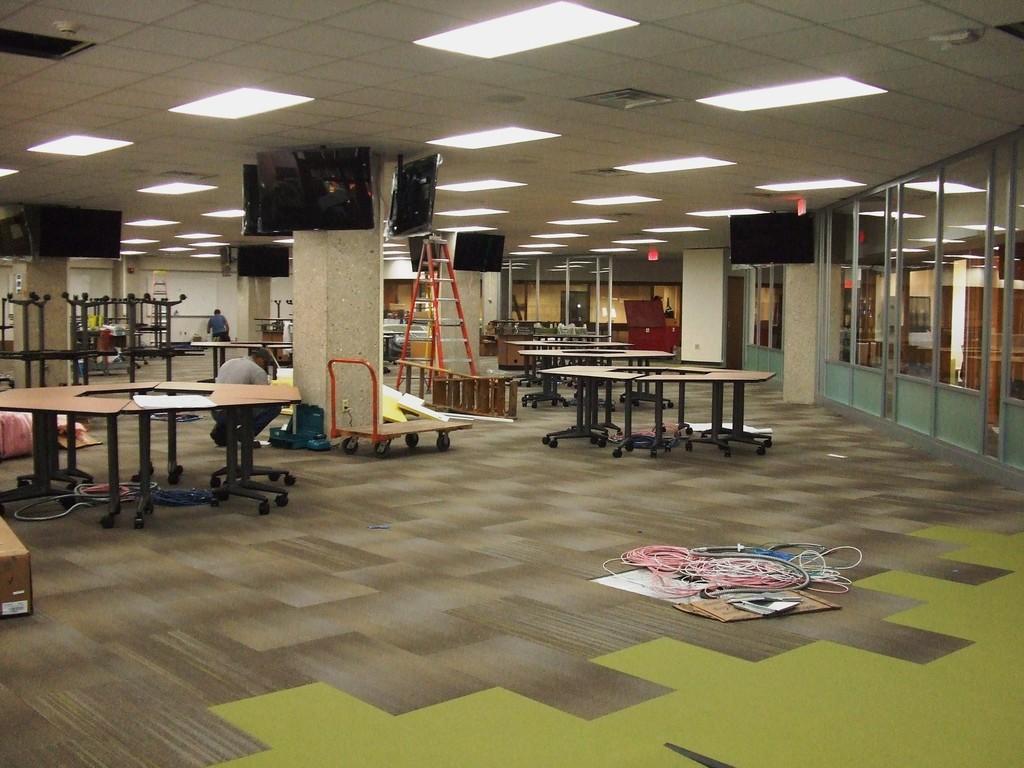Describe this image in one or two sentences. These are the tables with wheels attached to it. I can see the TV screens, which are attached to the wall. These are the pillars. This looks like a ladder. I can see a person sitting in squat position. I think these are the wires, cardboard box and few other things placed on the floor. This is the glass door. I can see the ceiling lights, which are attached to the roof. This looks like a wheel cart. 